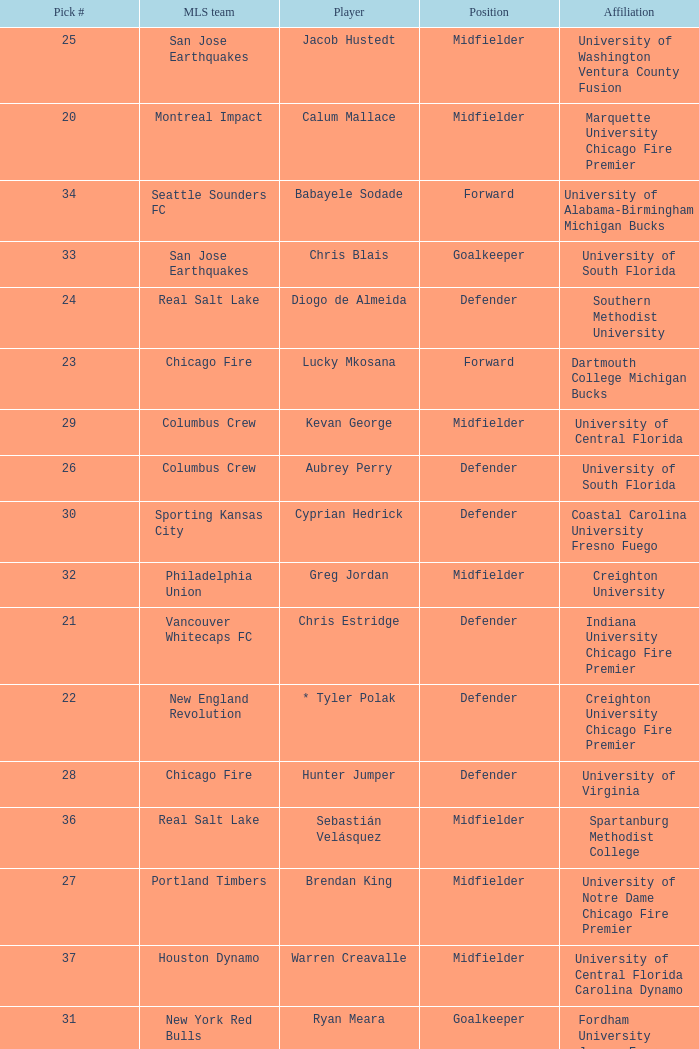What pick number is Kevan George? 29.0. 